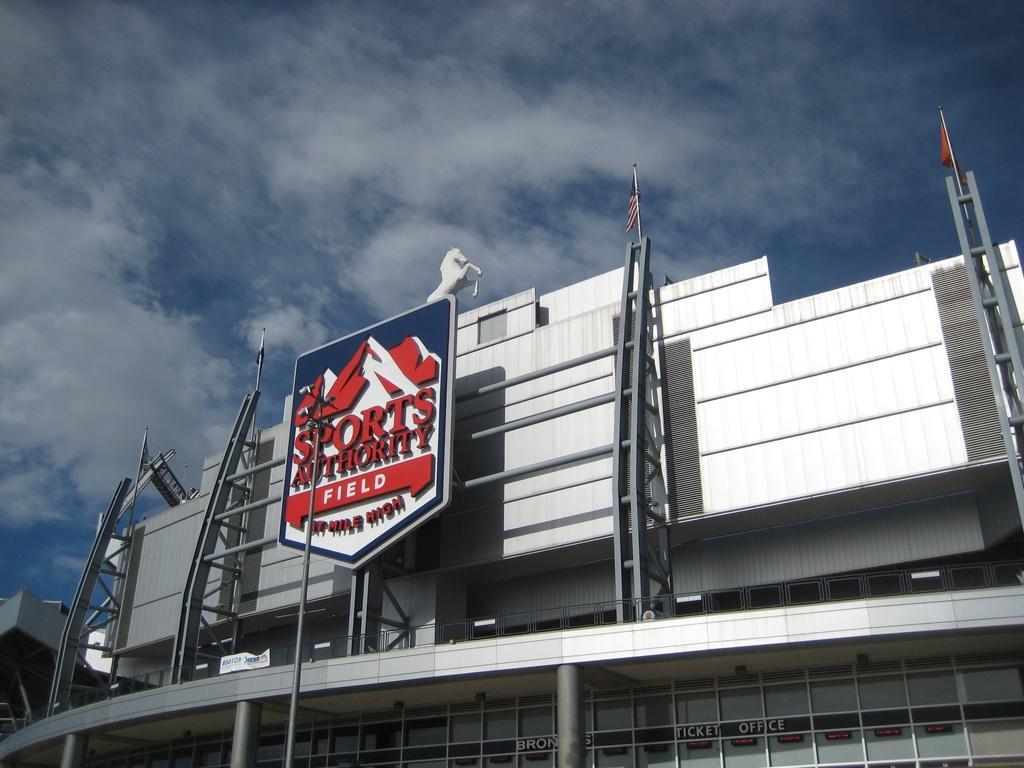How would you summarize this image in a sentence or two? In this image there is a building and there are flags on the top of the building, depiction of a horse and a board with some text. In the background there is the sky. 